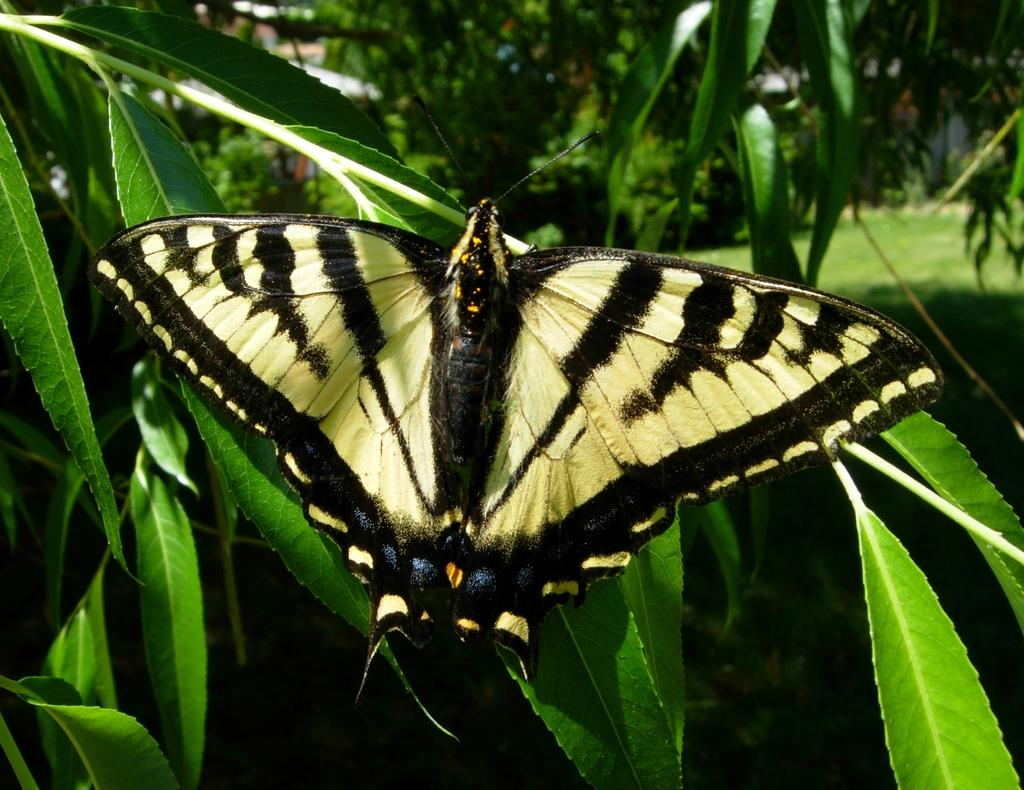What is on the leaf in the image? There is a butterfly on a leaf in the image. What can be seen in the background of the image? There are trees and grass in the background of the image. What type of loaf is being used as a perch for the butterfly in the image? There is no loaf present in the image; the butterfly is on a leaf. 